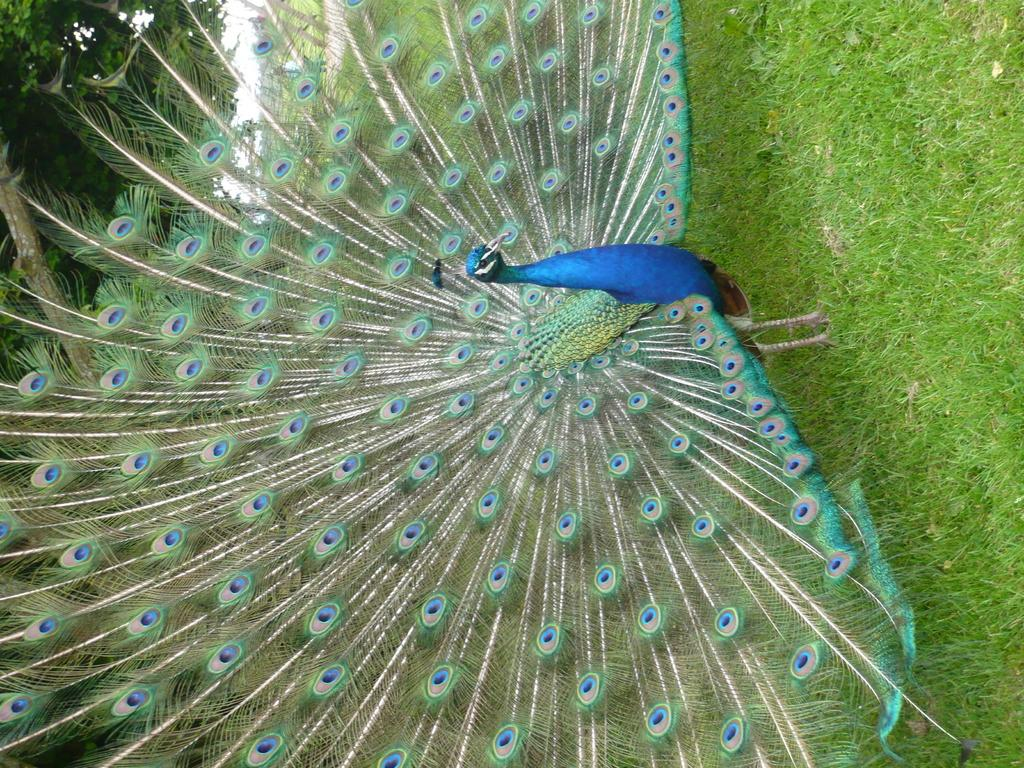What animal is the main subject of the image? There is a peacock in the image. Where is the peacock located in the image? The peacock is standing on the grass. What can be seen in the background of the image? There are trees and the sky visible in the background of the image. What type of brush is the peacock using to paint a picture in the image? There is no brush or painting activity present in the image; it features a peacock standing on the grass. What kind of meal is the peacock eating in the image? There is no meal or eating activity present in the image; it features a peacock standing on the grass. 